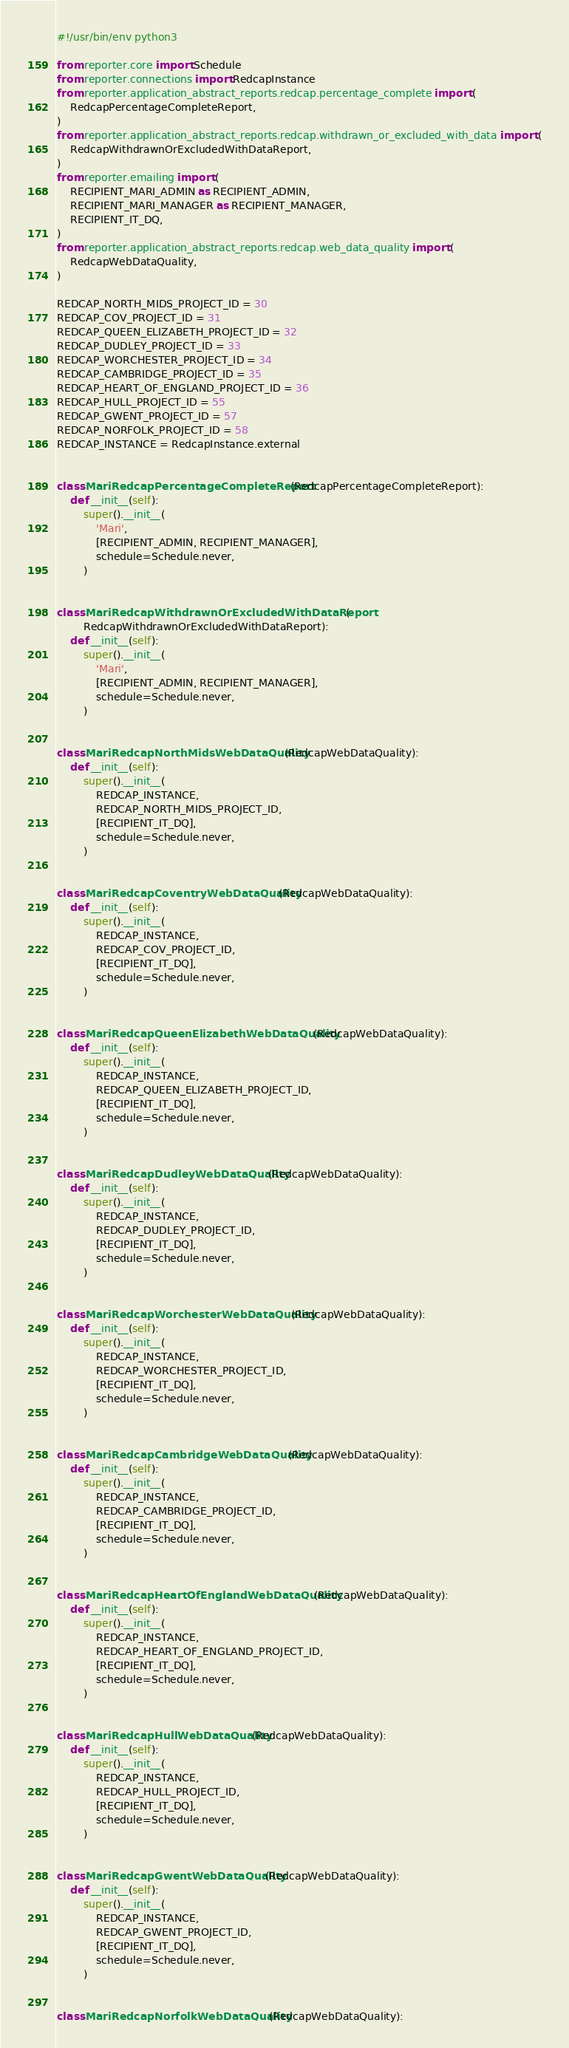Convert code to text. <code><loc_0><loc_0><loc_500><loc_500><_Python_>#!/usr/bin/env python3

from reporter.core import Schedule
from reporter.connections import RedcapInstance
from reporter.application_abstract_reports.redcap.percentage_complete import (
    RedcapPercentageCompleteReport,
)
from reporter.application_abstract_reports.redcap.withdrawn_or_excluded_with_data import (
    RedcapWithdrawnOrExcludedWithDataReport,
)
from reporter.emailing import (
    RECIPIENT_MARI_ADMIN as RECIPIENT_ADMIN,
    RECIPIENT_MARI_MANAGER as RECIPIENT_MANAGER,
    RECIPIENT_IT_DQ,
)
from reporter.application_abstract_reports.redcap.web_data_quality import (
    RedcapWebDataQuality,
)

REDCAP_NORTH_MIDS_PROJECT_ID = 30
REDCAP_COV_PROJECT_ID = 31
REDCAP_QUEEN_ELIZABETH_PROJECT_ID = 32
REDCAP_DUDLEY_PROJECT_ID = 33
REDCAP_WORCHESTER_PROJECT_ID = 34
REDCAP_CAMBRIDGE_PROJECT_ID = 35
REDCAP_HEART_OF_ENGLAND_PROJECT_ID = 36
REDCAP_HULL_PROJECT_ID = 55
REDCAP_GWENT_PROJECT_ID = 57
REDCAP_NORFOLK_PROJECT_ID = 58
REDCAP_INSTANCE = RedcapInstance.external


class MariRedcapPercentageCompleteReport(RedcapPercentageCompleteReport):
    def __init__(self):
        super().__init__(
            'Mari',
            [RECIPIENT_ADMIN, RECIPIENT_MANAGER],
            schedule=Schedule.never,
        )


class MariRedcapWithdrawnOrExcludedWithDataReport(
        RedcapWithdrawnOrExcludedWithDataReport):
    def __init__(self):
        super().__init__(
            'Mari',
            [RECIPIENT_ADMIN, RECIPIENT_MANAGER],
            schedule=Schedule.never,
        )


class MariRedcapNorthMidsWebDataQuality(RedcapWebDataQuality):
    def __init__(self):
        super().__init__(
            REDCAP_INSTANCE,
            REDCAP_NORTH_MIDS_PROJECT_ID,
            [RECIPIENT_IT_DQ],
            schedule=Schedule.never,
        )


class MariRedcapCoventryWebDataQuality(RedcapWebDataQuality):
    def __init__(self):
        super().__init__(
            REDCAP_INSTANCE,
            REDCAP_COV_PROJECT_ID,
            [RECIPIENT_IT_DQ],
            schedule=Schedule.never,
        )


class MariRedcapQueenElizabethWebDataQuality(RedcapWebDataQuality):
    def __init__(self):
        super().__init__(
            REDCAP_INSTANCE,
            REDCAP_QUEEN_ELIZABETH_PROJECT_ID,
            [RECIPIENT_IT_DQ],
            schedule=Schedule.never,
        )


class MariRedcapDudleyWebDataQuality(RedcapWebDataQuality):
    def __init__(self):
        super().__init__(
            REDCAP_INSTANCE,
            REDCAP_DUDLEY_PROJECT_ID,
            [RECIPIENT_IT_DQ],
            schedule=Schedule.never,
        )


class MariRedcapWorchesterWebDataQuality(RedcapWebDataQuality):
    def __init__(self):
        super().__init__(
            REDCAP_INSTANCE,
            REDCAP_WORCHESTER_PROJECT_ID,
            [RECIPIENT_IT_DQ],
            schedule=Schedule.never,
        )


class MariRedcapCambridgeWebDataQuality(RedcapWebDataQuality):
    def __init__(self):
        super().__init__(
            REDCAP_INSTANCE,
            REDCAP_CAMBRIDGE_PROJECT_ID,
            [RECIPIENT_IT_DQ],
            schedule=Schedule.never,
        )


class MariRedcapHeartOfEnglandWebDataQuality(RedcapWebDataQuality):
    def __init__(self):
        super().__init__(
            REDCAP_INSTANCE,
            REDCAP_HEART_OF_ENGLAND_PROJECT_ID,
            [RECIPIENT_IT_DQ],
            schedule=Schedule.never,
        )


class MariRedcapHullWebDataQuality(RedcapWebDataQuality):
    def __init__(self):
        super().__init__(
            REDCAP_INSTANCE,
            REDCAP_HULL_PROJECT_ID,
            [RECIPIENT_IT_DQ],
            schedule=Schedule.never,
        )


class MariRedcapGwentWebDataQuality(RedcapWebDataQuality):
    def __init__(self):
        super().__init__(
            REDCAP_INSTANCE,
            REDCAP_GWENT_PROJECT_ID,
            [RECIPIENT_IT_DQ],
            schedule=Schedule.never,
        )


class MariRedcapNorfolkWebDataQuality(RedcapWebDataQuality):</code> 